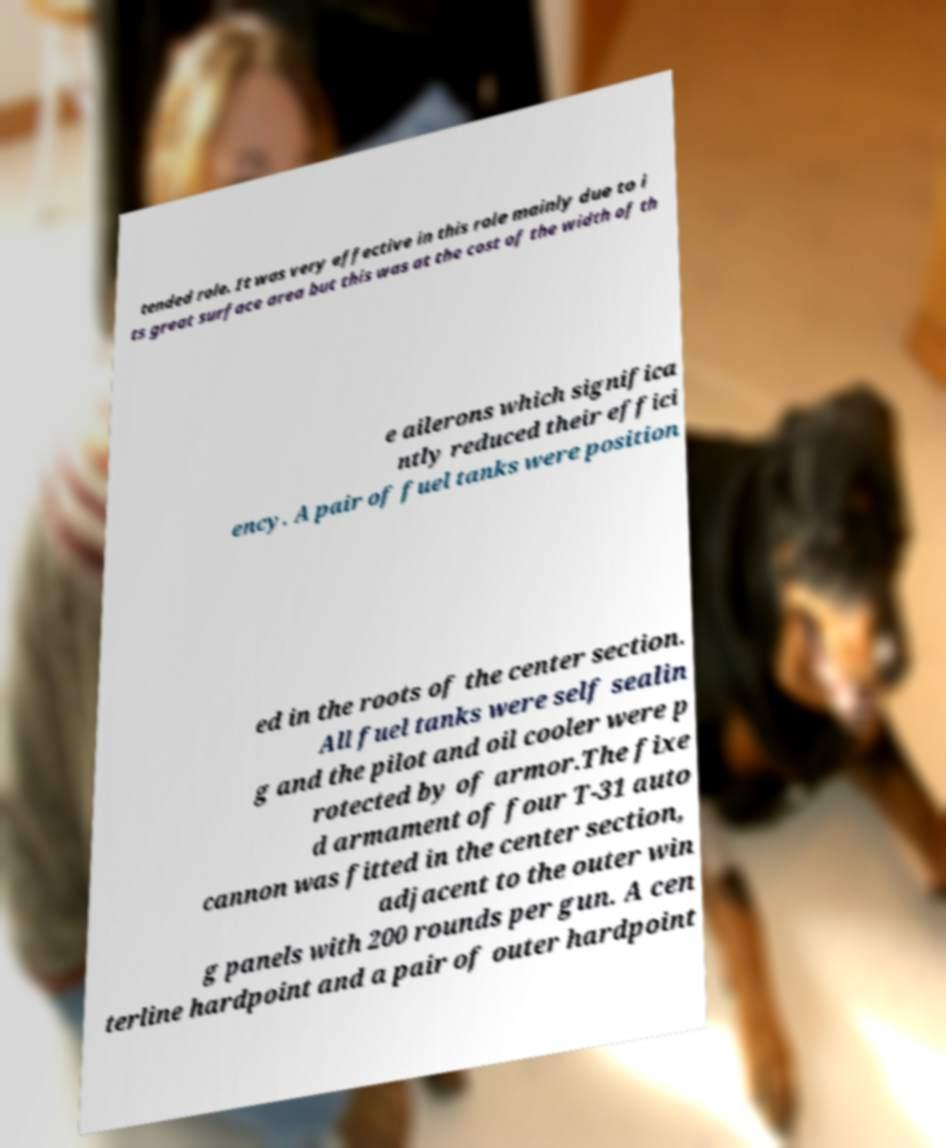Can you read and provide the text displayed in the image?This photo seems to have some interesting text. Can you extract and type it out for me? tended role. It was very effective in this role mainly due to i ts great surface area but this was at the cost of the width of th e ailerons which significa ntly reduced their effici ency. A pair of fuel tanks were position ed in the roots of the center section. All fuel tanks were self sealin g and the pilot and oil cooler were p rotected by of armor.The fixe d armament of four T-31 auto cannon was fitted in the center section, adjacent to the outer win g panels with 200 rounds per gun. A cen terline hardpoint and a pair of outer hardpoint 